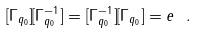<formula> <loc_0><loc_0><loc_500><loc_500>[ \Gamma _ { q _ { 0 } } ] [ \Gamma _ { q _ { 0 } } ^ { - 1 } ] = [ \Gamma _ { q _ { 0 } } ^ { - 1 } ] [ \Gamma _ { q _ { 0 } } ] = e \ .</formula> 